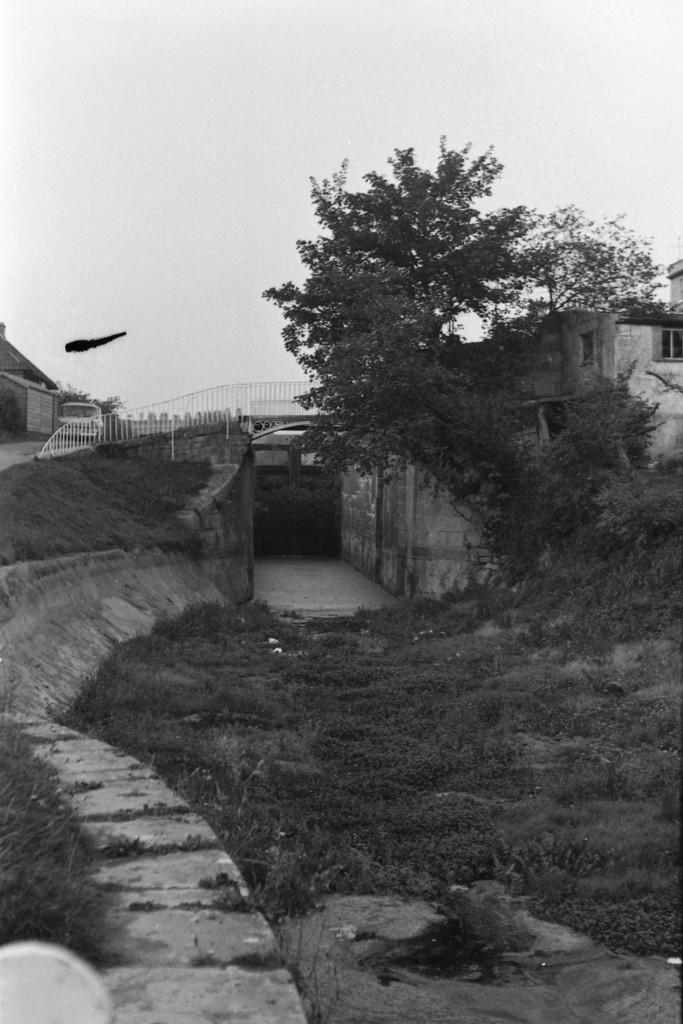What is the color scheme of the image? The image is black and white. What type of terrain is visible in the image? There is grass on the ground in the image. What natural elements can be seen in the image? There are trees in the image. What man-made structures are present in the image? There is a path, a bridge, a fence, and houses in the image. What architectural features can be observed in the houses? There are windows in the houses in the image. What else is present in the image besides the structures and natural elements? There are objects in the image. What part of the natural environment is visible in the image? The sky is visible in the image. Is there any quicksand visible in the image? There is no quicksand present in the image. How many heads can be seen in the image? There is no reference to any heads or people in the image, so it is not possible to determine the number of heads. 